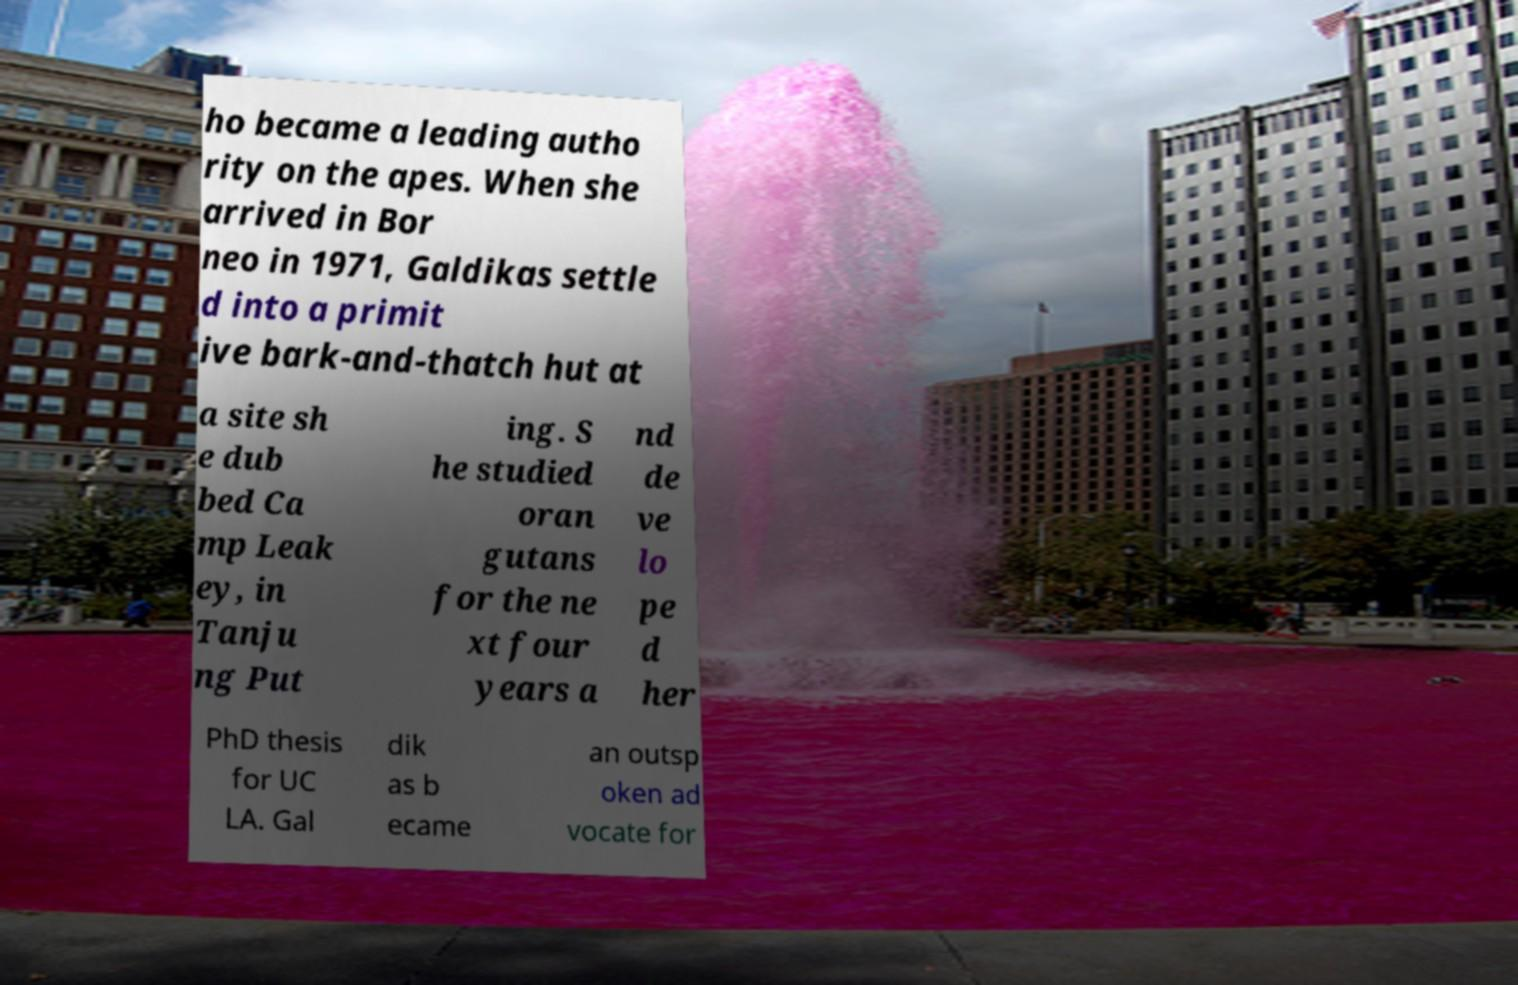Please read and relay the text visible in this image. What does it say? ho became a leading autho rity on the apes. When she arrived in Bor neo in 1971, Galdikas settle d into a primit ive bark-and-thatch hut at a site sh e dub bed Ca mp Leak ey, in Tanju ng Put ing. S he studied oran gutans for the ne xt four years a nd de ve lo pe d her PhD thesis for UC LA. Gal dik as b ecame an outsp oken ad vocate for 